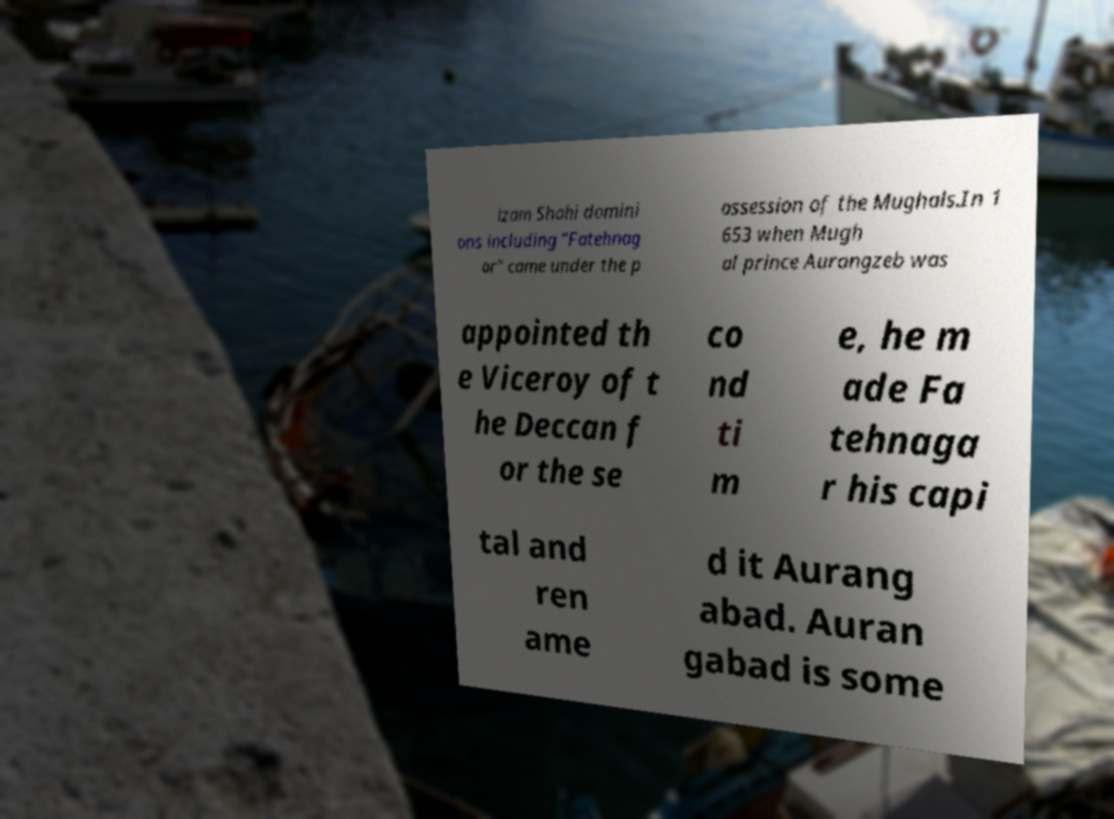Can you read and provide the text displayed in the image?This photo seems to have some interesting text. Can you extract and type it out for me? izam Shahi domini ons including "Fatehnag ar" came under the p ossession of the Mughals.In 1 653 when Mugh al prince Aurangzeb was appointed th e Viceroy of t he Deccan f or the se co nd ti m e, he m ade Fa tehnaga r his capi tal and ren ame d it Aurang abad. Auran gabad is some 